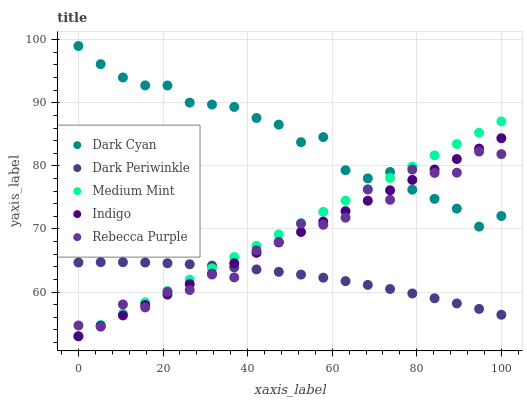Does Dark Periwinkle have the minimum area under the curve?
Answer yes or no. Yes. Does Dark Cyan have the maximum area under the curve?
Answer yes or no. Yes. Does Medium Mint have the minimum area under the curve?
Answer yes or no. No. Does Medium Mint have the maximum area under the curve?
Answer yes or no. No. Is Medium Mint the smoothest?
Answer yes or no. Yes. Is Rebecca Purple the roughest?
Answer yes or no. Yes. Is Indigo the smoothest?
Answer yes or no. No. Is Indigo the roughest?
Answer yes or no. No. Does Medium Mint have the lowest value?
Answer yes or no. Yes. Does Dark Periwinkle have the lowest value?
Answer yes or no. No. Does Dark Cyan have the highest value?
Answer yes or no. Yes. Does Medium Mint have the highest value?
Answer yes or no. No. Is Dark Periwinkle less than Dark Cyan?
Answer yes or no. Yes. Is Dark Cyan greater than Dark Periwinkle?
Answer yes or no. Yes. Does Indigo intersect Medium Mint?
Answer yes or no. Yes. Is Indigo less than Medium Mint?
Answer yes or no. No. Is Indigo greater than Medium Mint?
Answer yes or no. No. Does Dark Periwinkle intersect Dark Cyan?
Answer yes or no. No. 